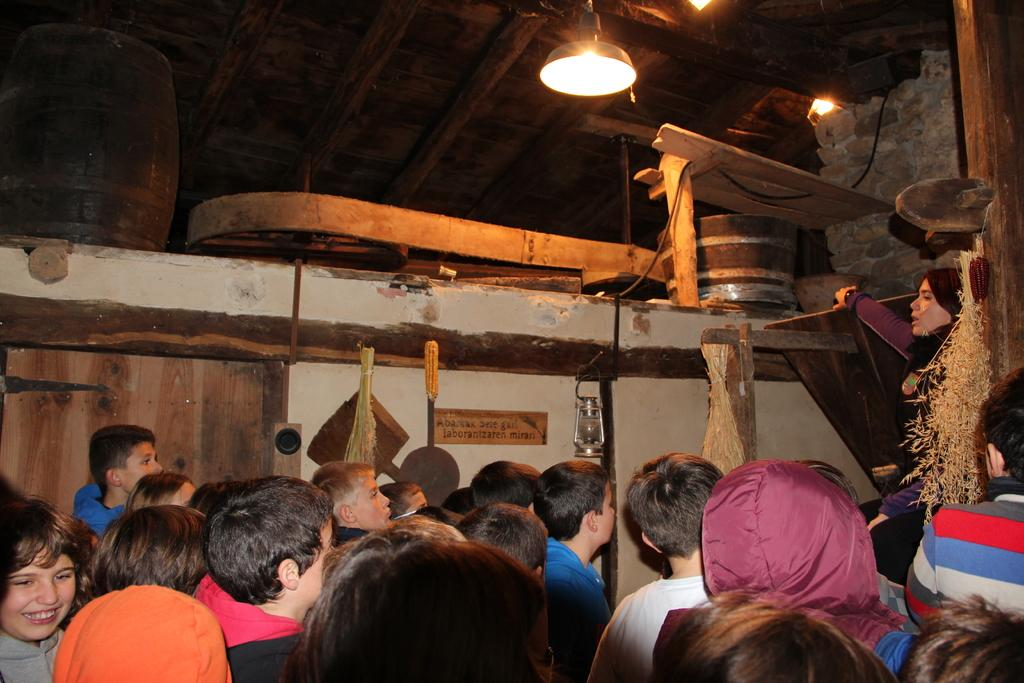Who or what can be seen in the image? There are people in the image. What is one object that provides light in the image? There is a lamp in the image. What surface might the people be using for writing or displaying information? There is a board in the image. What type of lighting is present in the image? There are lights in the image. What material is used for some of the objects in the image? There are wooden objects in the image. What type of camera can be seen in the image? There is no camera present in the image. What part of the people's bodies is of particular interest in the image? The image does not focus on any specific part of the people's bodies; it shows them as a whole. 